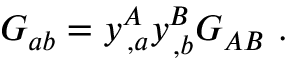<formula> <loc_0><loc_0><loc_500><loc_500>G _ { a b } = y _ { \, , a } ^ { A } y _ { \, , b } ^ { B } G _ { A B } .</formula> 